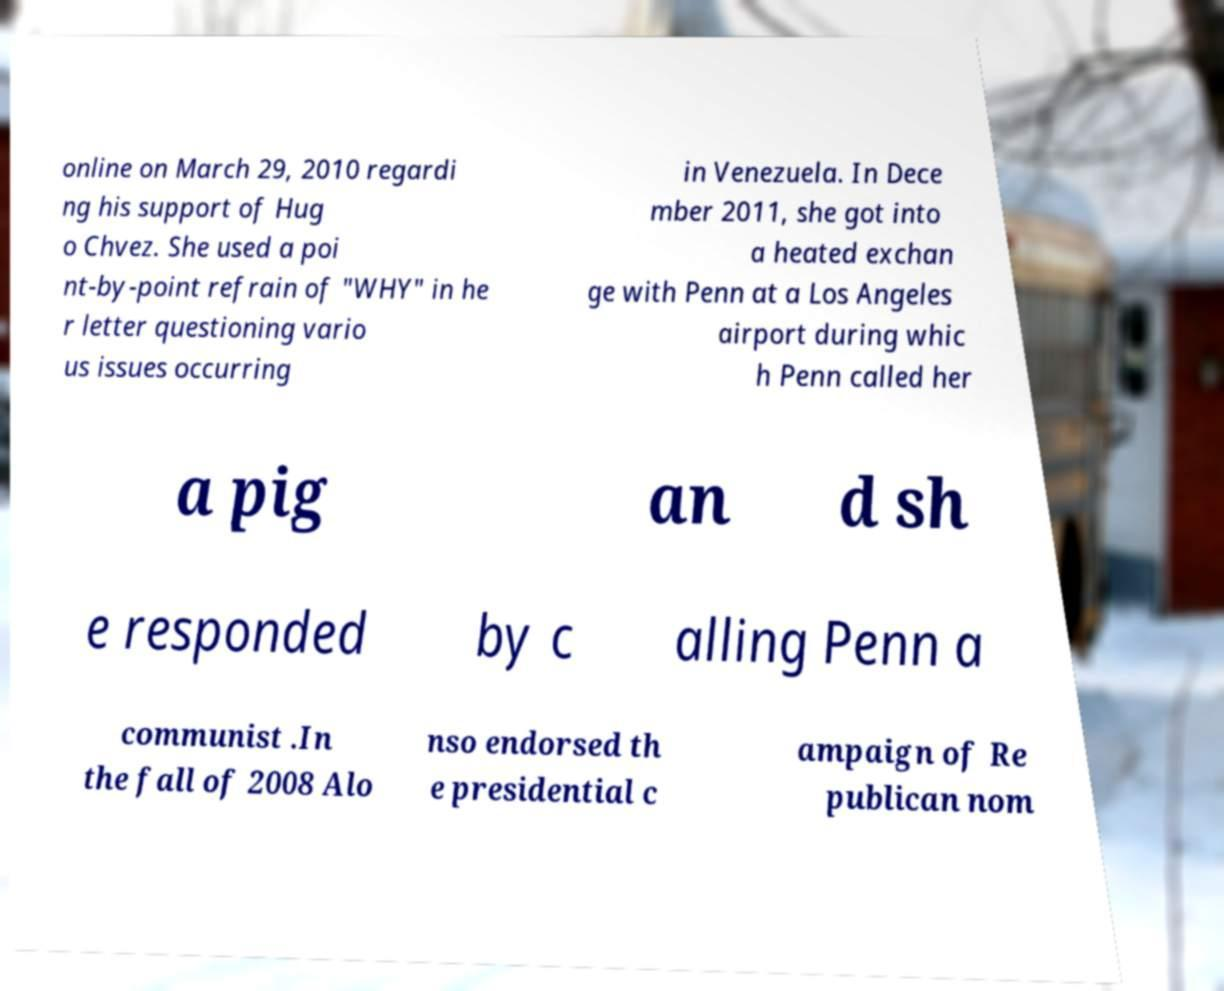Can you read and provide the text displayed in the image?This photo seems to have some interesting text. Can you extract and type it out for me? online on March 29, 2010 regardi ng his support of Hug o Chvez. She used a poi nt-by-point refrain of "WHY" in he r letter questioning vario us issues occurring in Venezuela. In Dece mber 2011, she got into a heated exchan ge with Penn at a Los Angeles airport during whic h Penn called her a pig an d sh e responded by c alling Penn a communist .In the fall of 2008 Alo nso endorsed th e presidential c ampaign of Re publican nom 